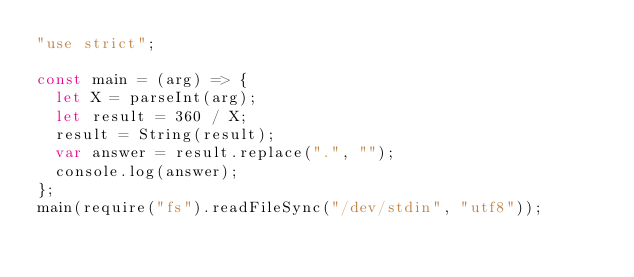Convert code to text. <code><loc_0><loc_0><loc_500><loc_500><_JavaScript_>"use strict";

const main = (arg) => {
  let X = parseInt(arg);
  let result = 360 / X;
  result = String(result);
  var answer = result.replace(".", "");
  console.log(answer);
};
main(require("fs").readFileSync("/dev/stdin", "utf8"));</code> 